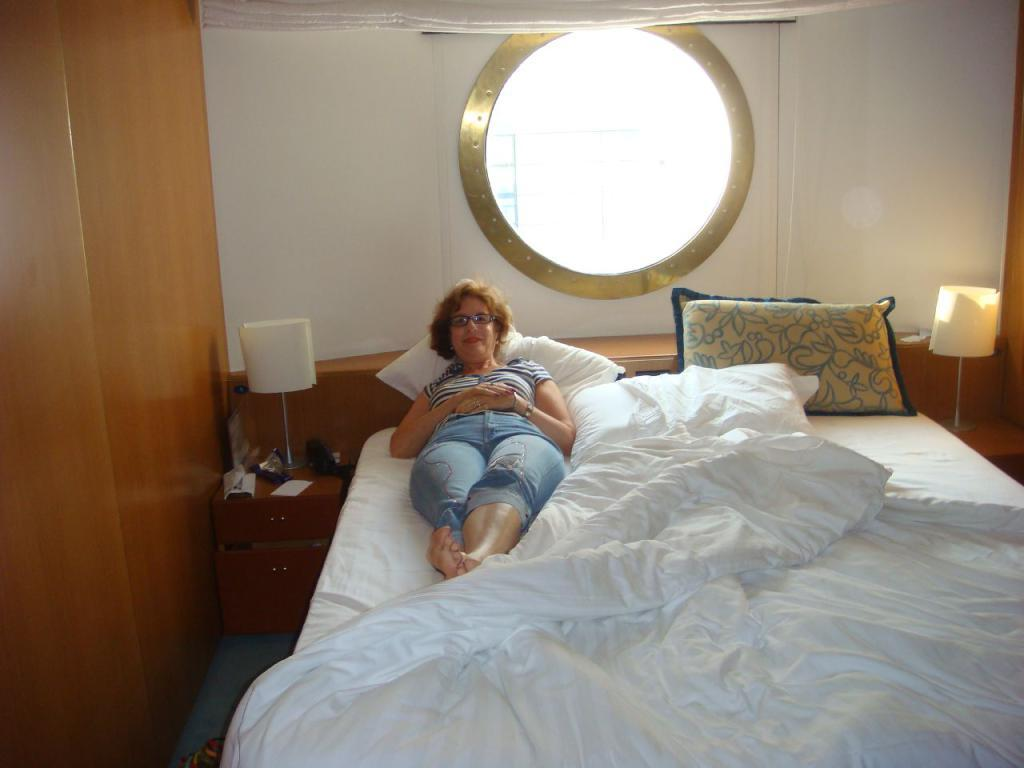What is the woman doing in the image? The woman is laying on a bed in the image. What is on the bed with the woman? There is a pillow on the bed. What is located beside the bed? There is a table beside the bed. What is on the table? There is a lantern lamp and papers on the table. Is there any source of natural light in the room? Yes, there is a window in the room. What type of eggnog is being served by the band in the image? There is no eggnog or band present in the image. 